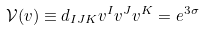<formula> <loc_0><loc_0><loc_500><loc_500>\mathcal { V } ( v ) \equiv d _ { I J K } v ^ { I } v ^ { J } v ^ { K } = e ^ { 3 \sigma }</formula> 